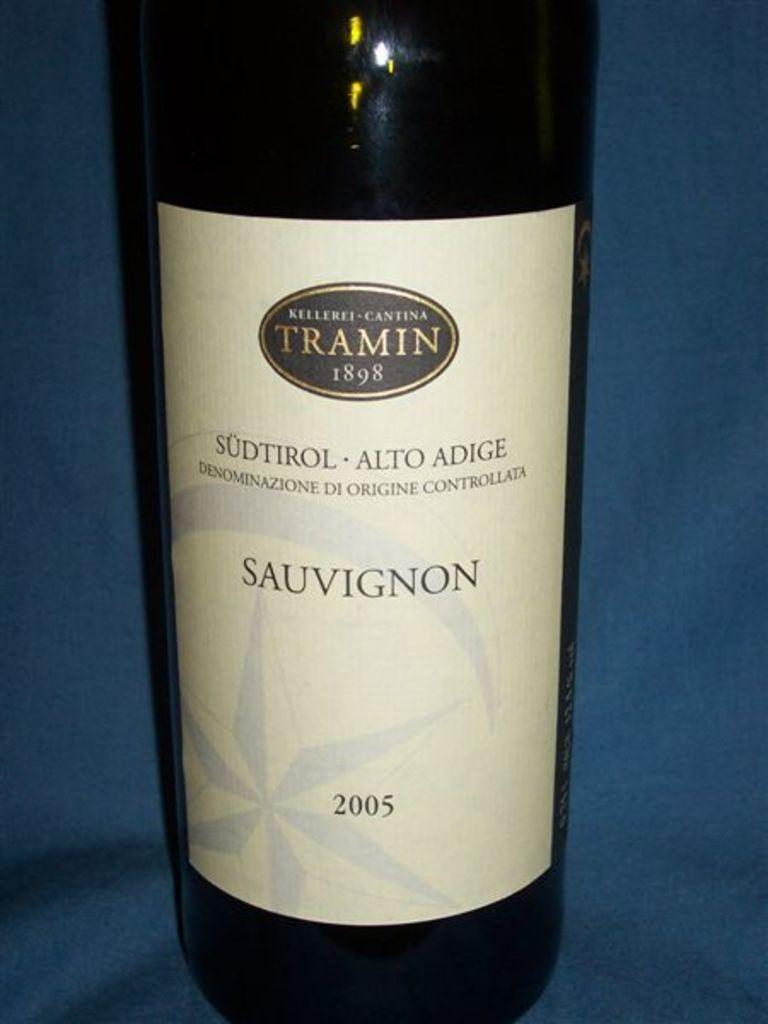<image>
Offer a succinct explanation of the picture presented. A bottle of sauvignon wine from the maker Tramin. 